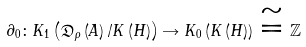Convert formula to latex. <formula><loc_0><loc_0><loc_500><loc_500>\partial _ { 0 } \colon K _ { 1 } \left ( \mathfrak { D } _ { \rho } \left ( A \right ) / K \left ( H \right ) \right ) \rightarrow K _ { 0 } \left ( K \left ( H \right ) \right ) \cong \mathbb { Z }</formula> 